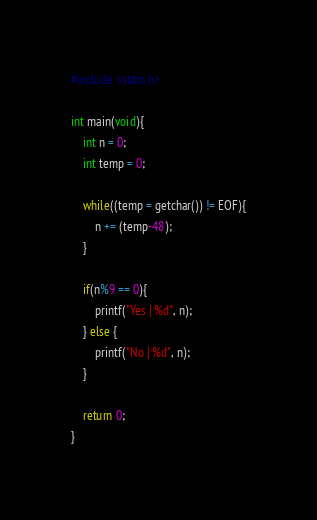Convert code to text. <code><loc_0><loc_0><loc_500><loc_500><_C_>#include <stdio.h>

int main(void){
    int n = 0;
    int temp = 0;
    
    while((temp = getchar()) != EOF){
        n += (temp-48);
    }

    if(n%9 == 0){
        printf("Yes | %d", n);
    } else {
        printf("No | %d", n);
    }
    
    return 0;
}</code> 